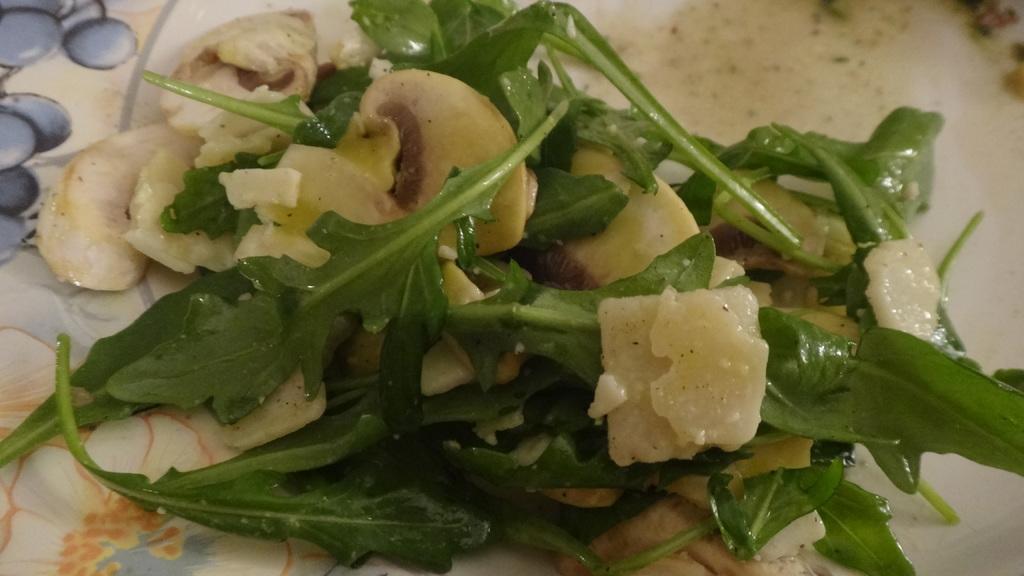Could you give a brief overview of what you see in this image? In the foreground of this image, there is some food and green leafy vegetable on a platter. 